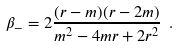<formula> <loc_0><loc_0><loc_500><loc_500>\beta _ { - } = 2 \frac { ( r - m ) ( r - 2 m ) } { m ^ { 2 } - 4 m r + 2 r ^ { 2 } } \ .</formula> 